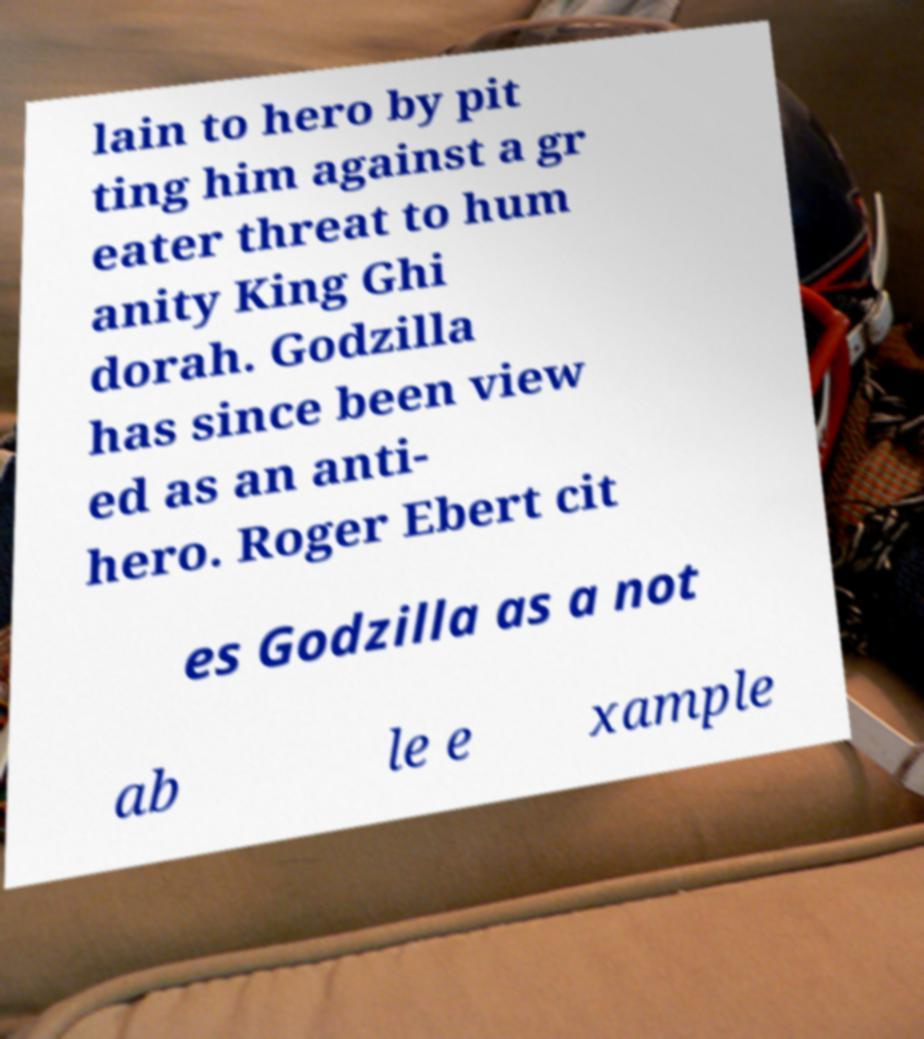Can you accurately transcribe the text from the provided image for me? lain to hero by pit ting him against a gr eater threat to hum anity King Ghi dorah. Godzilla has since been view ed as an anti- hero. Roger Ebert cit es Godzilla as a not ab le e xample 